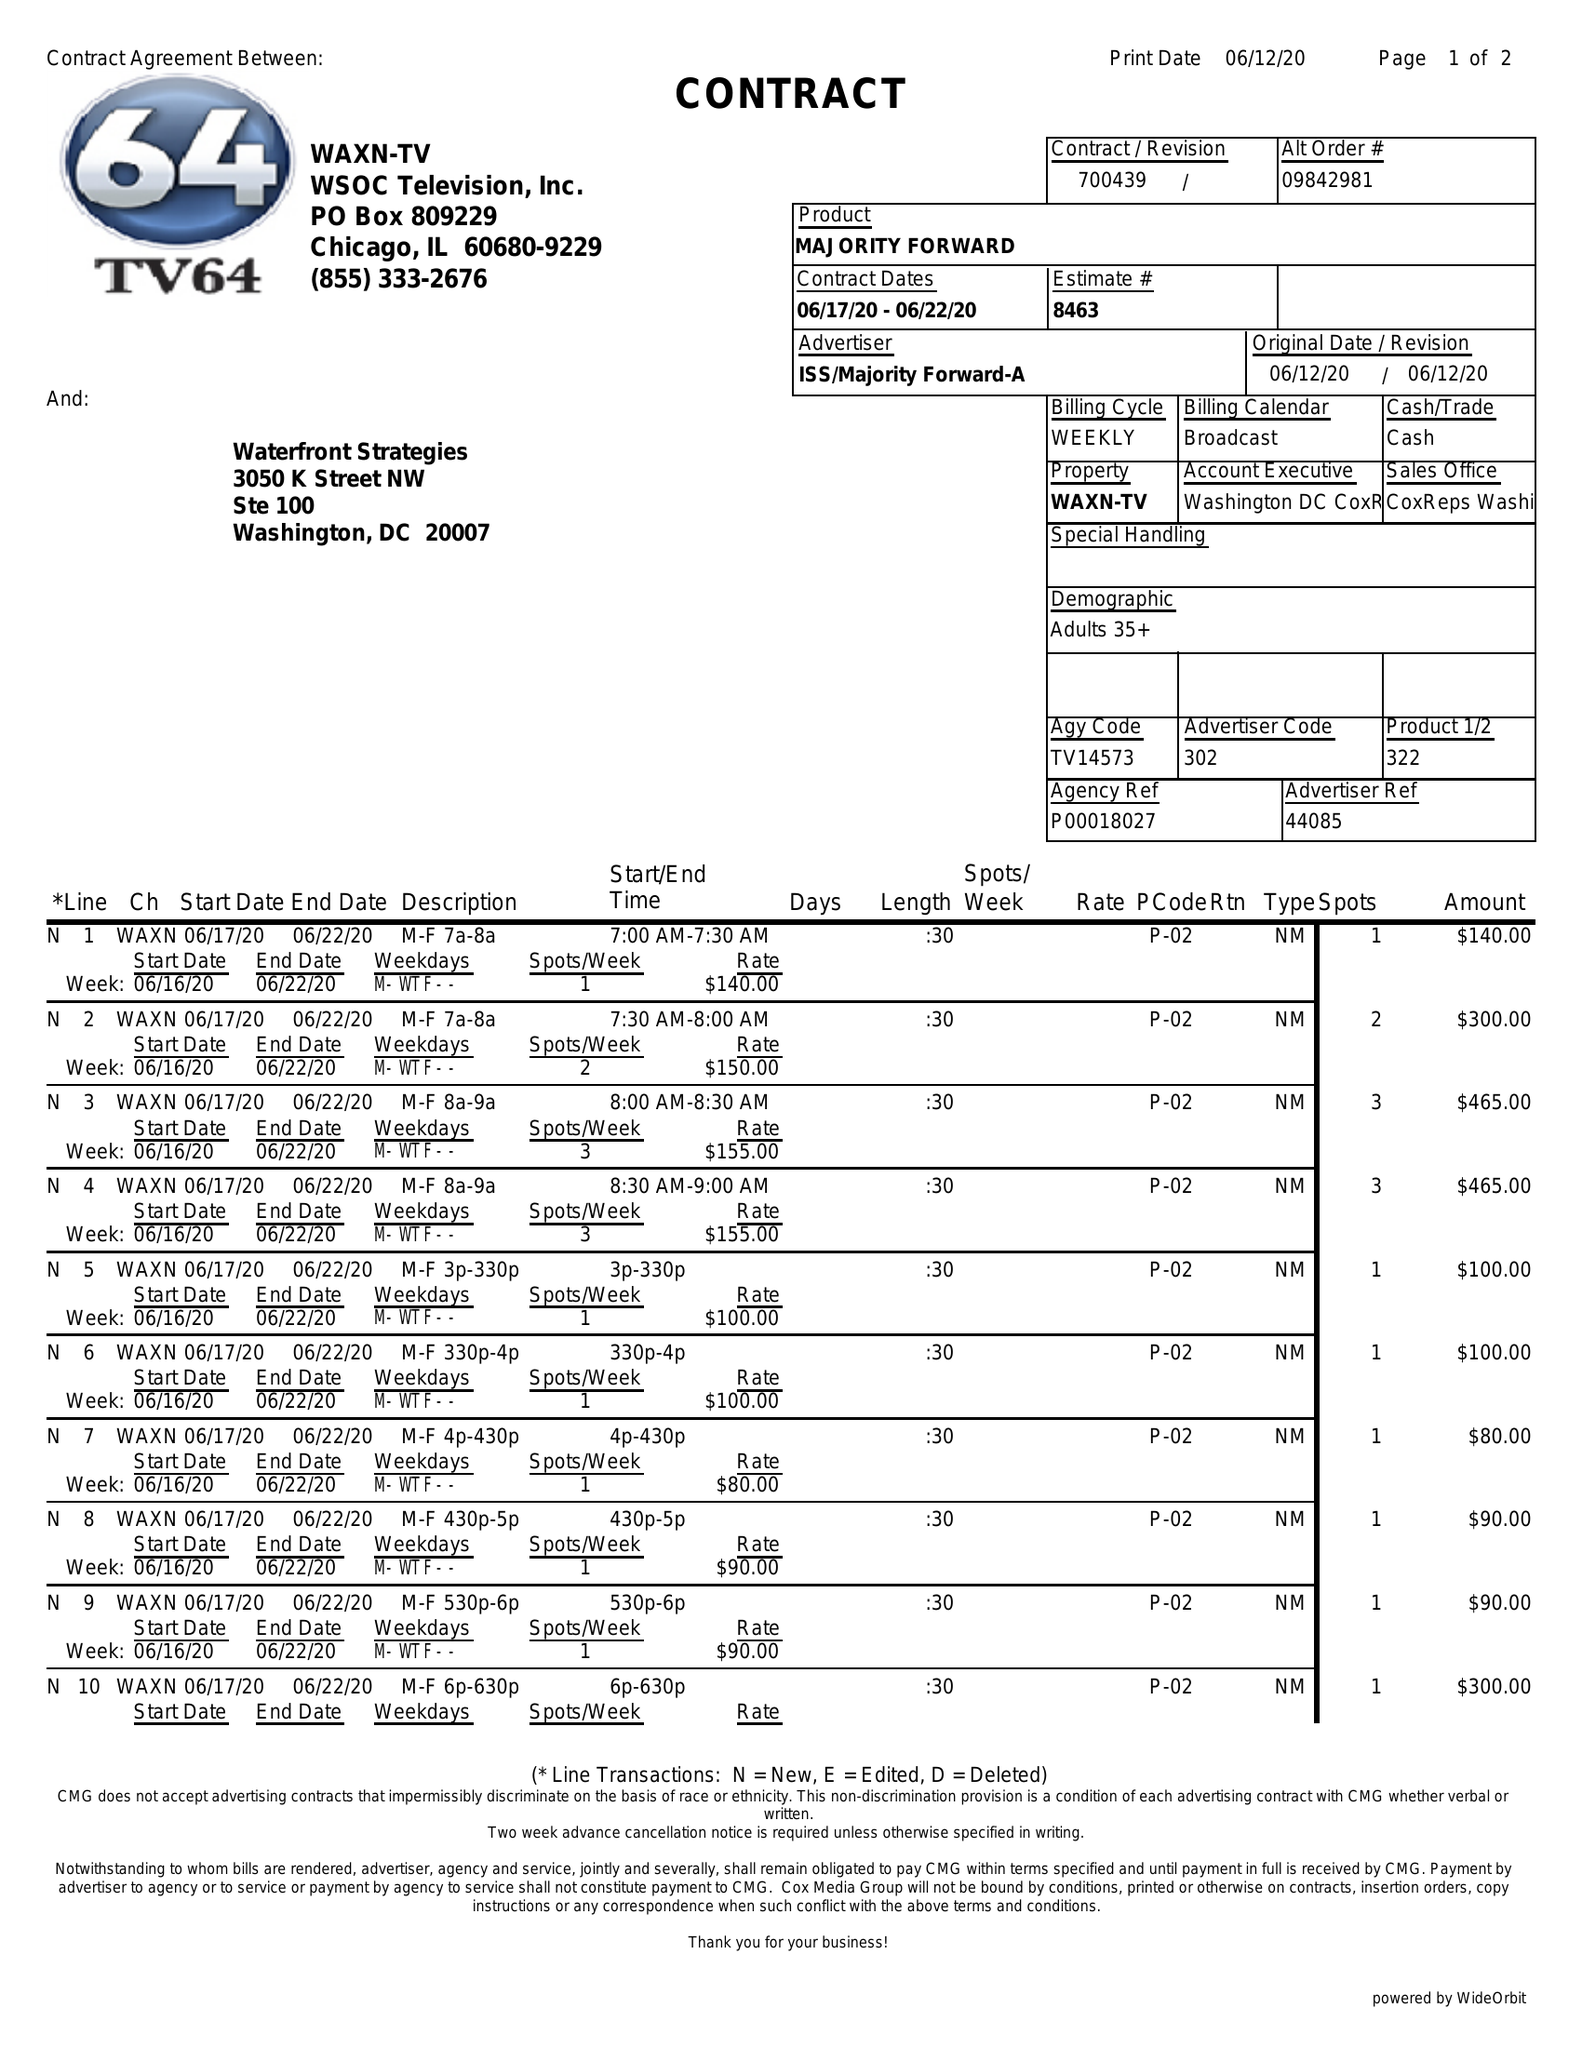What is the value for the gross_amount?
Answer the question using a single word or phrase. 9030.00 